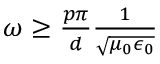<formula> <loc_0><loc_0><loc_500><loc_500>\begin{array} { r } { \omega \geq \frac { p \pi } { d } \frac { 1 } { \sqrt { \mu _ { 0 } \epsilon _ { 0 } } } } \end{array}</formula> 